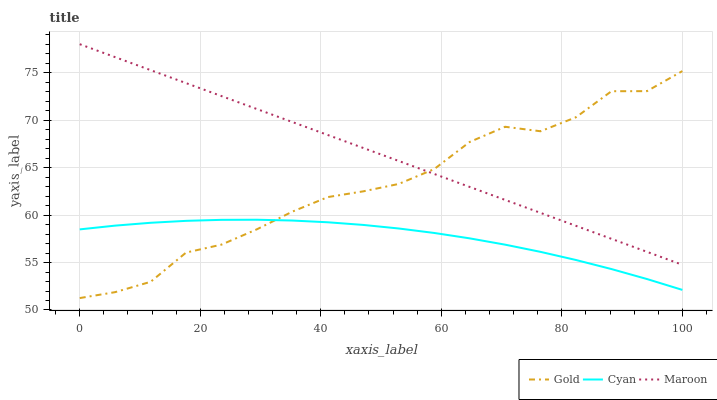Does Cyan have the minimum area under the curve?
Answer yes or no. Yes. Does Maroon have the maximum area under the curve?
Answer yes or no. Yes. Does Gold have the minimum area under the curve?
Answer yes or no. No. Does Gold have the maximum area under the curve?
Answer yes or no. No. Is Maroon the smoothest?
Answer yes or no. Yes. Is Gold the roughest?
Answer yes or no. Yes. Is Gold the smoothest?
Answer yes or no. No. Is Maroon the roughest?
Answer yes or no. No. Does Gold have the lowest value?
Answer yes or no. Yes. Does Maroon have the lowest value?
Answer yes or no. No. Does Maroon have the highest value?
Answer yes or no. Yes. Does Gold have the highest value?
Answer yes or no. No. Is Cyan less than Maroon?
Answer yes or no. Yes. Is Maroon greater than Cyan?
Answer yes or no. Yes. Does Maroon intersect Gold?
Answer yes or no. Yes. Is Maroon less than Gold?
Answer yes or no. No. Is Maroon greater than Gold?
Answer yes or no. No. Does Cyan intersect Maroon?
Answer yes or no. No. 